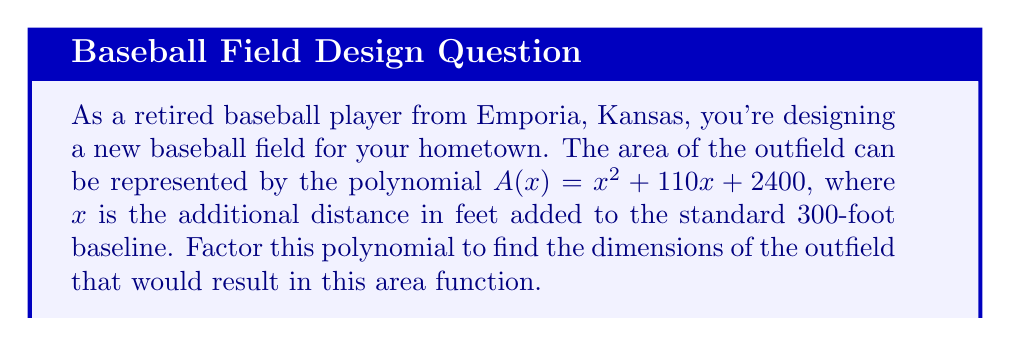Teach me how to tackle this problem. To factor the polynomial $A(x) = x^2 + 110x + 2400$, we'll use the following steps:

1) First, identify that this is a quadratic equation in the form $ax^2 + bx + c$, where:
   $a = 1$
   $b = 110$
   $c = 2400$

2) We'll use the ac-method for factoring. Multiply $a * c$:
   $1 * 2400 = 2400$

3) Find two numbers that multiply to give 2400 and add up to 110:
   $60 + 50 = 110$ and $60 * 50 = 2400$

4) Rewrite the middle term using these numbers:
   $A(x) = x^2 + 60x + 50x + 2400$

5) Factor by grouping:
   $A(x) = (x^2 + 60x) + (50x + 2400)$
   $A(x) = x(x + 60) + 50(x + 48)$

6) Factor out the common factor $(x + 48)$:
   $A(x) = (x + 50)(x + 48)$

This factored form represents the dimensions of the outfield. The two factors $(x + 50)$ and $(x + 48)$ represent the distances from home plate to the left and right field fences, respectively, when added to the standard 300-foot baseline.
Answer: $(x + 50)(x + 48)$ 